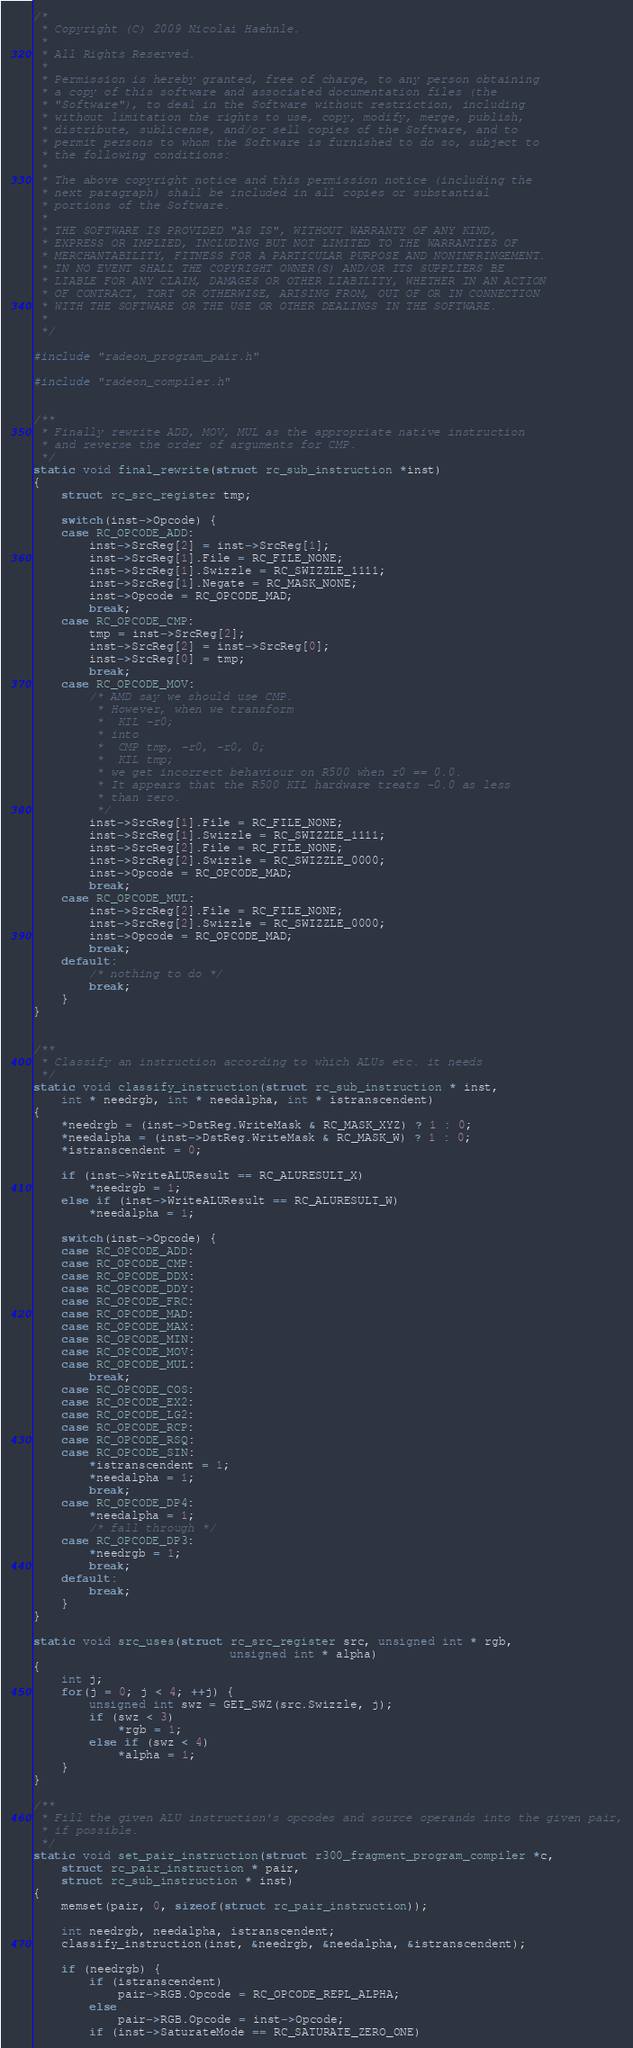<code> <loc_0><loc_0><loc_500><loc_500><_C_>/*
 * Copyright (C) 2009 Nicolai Haehnle.
 *
 * All Rights Reserved.
 *
 * Permission is hereby granted, free of charge, to any person obtaining
 * a copy of this software and associated documentation files (the
 * "Software"), to deal in the Software without restriction, including
 * without limitation the rights to use, copy, modify, merge, publish,
 * distribute, sublicense, and/or sell copies of the Software, and to
 * permit persons to whom the Software is furnished to do so, subject to
 * the following conditions:
 *
 * The above copyright notice and this permission notice (including the
 * next paragraph) shall be included in all copies or substantial
 * portions of the Software.
 *
 * THE SOFTWARE IS PROVIDED "AS IS", WITHOUT WARRANTY OF ANY KIND,
 * EXPRESS OR IMPLIED, INCLUDING BUT NOT LIMITED TO THE WARRANTIES OF
 * MERCHANTABILITY, FITNESS FOR A PARTICULAR PURPOSE AND NONINFRINGEMENT.
 * IN NO EVENT SHALL THE COPYRIGHT OWNER(S) AND/OR ITS SUPPLIERS BE
 * LIABLE FOR ANY CLAIM, DAMAGES OR OTHER LIABILITY, WHETHER IN AN ACTION
 * OF CONTRACT, TORT OR OTHERWISE, ARISING FROM, OUT OF OR IN CONNECTION
 * WITH THE SOFTWARE OR THE USE OR OTHER DEALINGS IN THE SOFTWARE.
 *
 */

#include "radeon_program_pair.h"

#include "radeon_compiler.h"


/**
 * Finally rewrite ADD, MOV, MUL as the appropriate native instruction
 * and reverse the order of arguments for CMP.
 */
static void final_rewrite(struct rc_sub_instruction *inst)
{
	struct rc_src_register tmp;

	switch(inst->Opcode) {
	case RC_OPCODE_ADD:
		inst->SrcReg[2] = inst->SrcReg[1];
		inst->SrcReg[1].File = RC_FILE_NONE;
		inst->SrcReg[1].Swizzle = RC_SWIZZLE_1111;
		inst->SrcReg[1].Negate = RC_MASK_NONE;
		inst->Opcode = RC_OPCODE_MAD;
		break;
	case RC_OPCODE_CMP:
		tmp = inst->SrcReg[2];
		inst->SrcReg[2] = inst->SrcReg[0];
		inst->SrcReg[0] = tmp;
		break;
	case RC_OPCODE_MOV:
		/* AMD say we should use CMP.
		 * However, when we transform
		 *  KIL -r0;
		 * into
		 *  CMP tmp, -r0, -r0, 0;
		 *  KIL tmp;
		 * we get incorrect behaviour on R500 when r0 == 0.0.
		 * It appears that the R500 KIL hardware treats -0.0 as less
		 * than zero.
		 */
		inst->SrcReg[1].File = RC_FILE_NONE;
		inst->SrcReg[1].Swizzle = RC_SWIZZLE_1111;
		inst->SrcReg[2].File = RC_FILE_NONE;
		inst->SrcReg[2].Swizzle = RC_SWIZZLE_0000;
		inst->Opcode = RC_OPCODE_MAD;
		break;
	case RC_OPCODE_MUL:
		inst->SrcReg[2].File = RC_FILE_NONE;
		inst->SrcReg[2].Swizzle = RC_SWIZZLE_0000;
		inst->Opcode = RC_OPCODE_MAD;
		break;
	default:
		/* nothing to do */
		break;
	}
}


/**
 * Classify an instruction according to which ALUs etc. it needs
 */
static void classify_instruction(struct rc_sub_instruction * inst,
	int * needrgb, int * needalpha, int * istranscendent)
{
	*needrgb = (inst->DstReg.WriteMask & RC_MASK_XYZ) ? 1 : 0;
	*needalpha = (inst->DstReg.WriteMask & RC_MASK_W) ? 1 : 0;
	*istranscendent = 0;

	if (inst->WriteALUResult == RC_ALURESULT_X)
		*needrgb = 1;
	else if (inst->WriteALUResult == RC_ALURESULT_W)
		*needalpha = 1;

	switch(inst->Opcode) {
	case RC_OPCODE_ADD:
	case RC_OPCODE_CMP:
	case RC_OPCODE_DDX:
	case RC_OPCODE_DDY:
	case RC_OPCODE_FRC:
	case RC_OPCODE_MAD:
	case RC_OPCODE_MAX:
	case RC_OPCODE_MIN:
	case RC_OPCODE_MOV:
	case RC_OPCODE_MUL:
		break;
	case RC_OPCODE_COS:
	case RC_OPCODE_EX2:
	case RC_OPCODE_LG2:
	case RC_OPCODE_RCP:
	case RC_OPCODE_RSQ:
	case RC_OPCODE_SIN:
		*istranscendent = 1;
		*needalpha = 1;
		break;
	case RC_OPCODE_DP4:
		*needalpha = 1;
		/* fall through */
	case RC_OPCODE_DP3:
		*needrgb = 1;
		break;
	default:
		break;
	}
}

static void src_uses(struct rc_src_register src, unsigned int * rgb,
							unsigned int * alpha)
{
	int j;
	for(j = 0; j < 4; ++j) {
		unsigned int swz = GET_SWZ(src.Swizzle, j);
		if (swz < 3)
			*rgb = 1;
		else if (swz < 4)
			*alpha = 1;
	}
}

/**
 * Fill the given ALU instruction's opcodes and source operands into the given pair,
 * if possible.
 */
static void set_pair_instruction(struct r300_fragment_program_compiler *c,
	struct rc_pair_instruction * pair,
	struct rc_sub_instruction * inst)
{
	memset(pair, 0, sizeof(struct rc_pair_instruction));

	int needrgb, needalpha, istranscendent;
	classify_instruction(inst, &needrgb, &needalpha, &istranscendent);

	if (needrgb) {
		if (istranscendent)
			pair->RGB.Opcode = RC_OPCODE_REPL_ALPHA;
		else
			pair->RGB.Opcode = inst->Opcode;
		if (inst->SaturateMode == RC_SATURATE_ZERO_ONE)</code> 